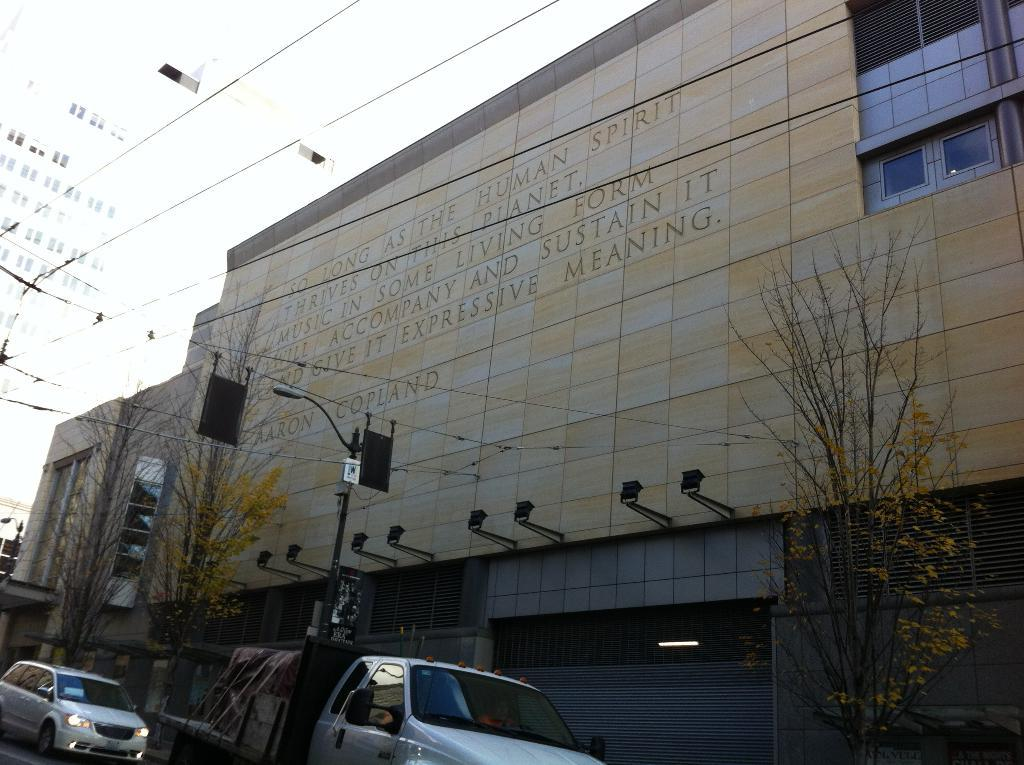What type of structures are present in the image? There are buildings in the image. What other natural elements can be seen in the image? There are trees in the image. What else is present in the image besides buildings and trees? There are poles with wires and vehicles in the image. What is visible at the top of the image? The sky is visible at the top of the image. Can you tell me how many crooks are depicted in the image? There are no crooks present in the image; it features buildings, trees, poles with wires, vehicles, and the sky. What type of stick is being used to spread hate in the image? There is no stick or any indication of hate present in the image. 